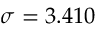Convert formula to latex. <formula><loc_0><loc_0><loc_500><loc_500>\sigma = 3 . 4 1 0</formula> 